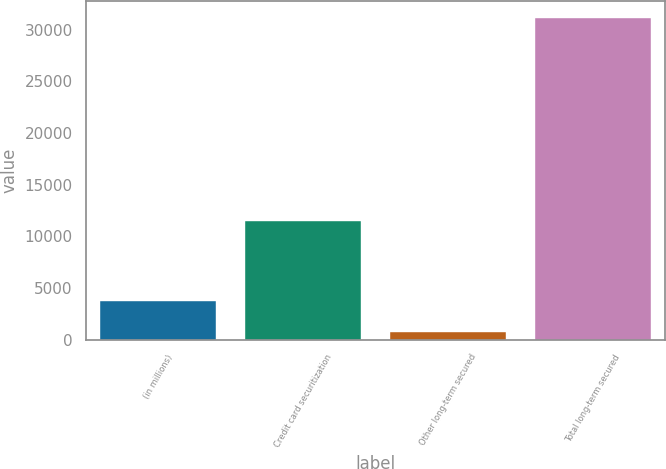Convert chart to OTSL. <chart><loc_0><loc_0><loc_500><loc_500><bar_chart><fcel>(in millions)<fcel>Credit card securitization<fcel>Other long-term secured<fcel>Total long-term secured<nl><fcel>3773.5<fcel>11470<fcel>731<fcel>31156<nl></chart> 